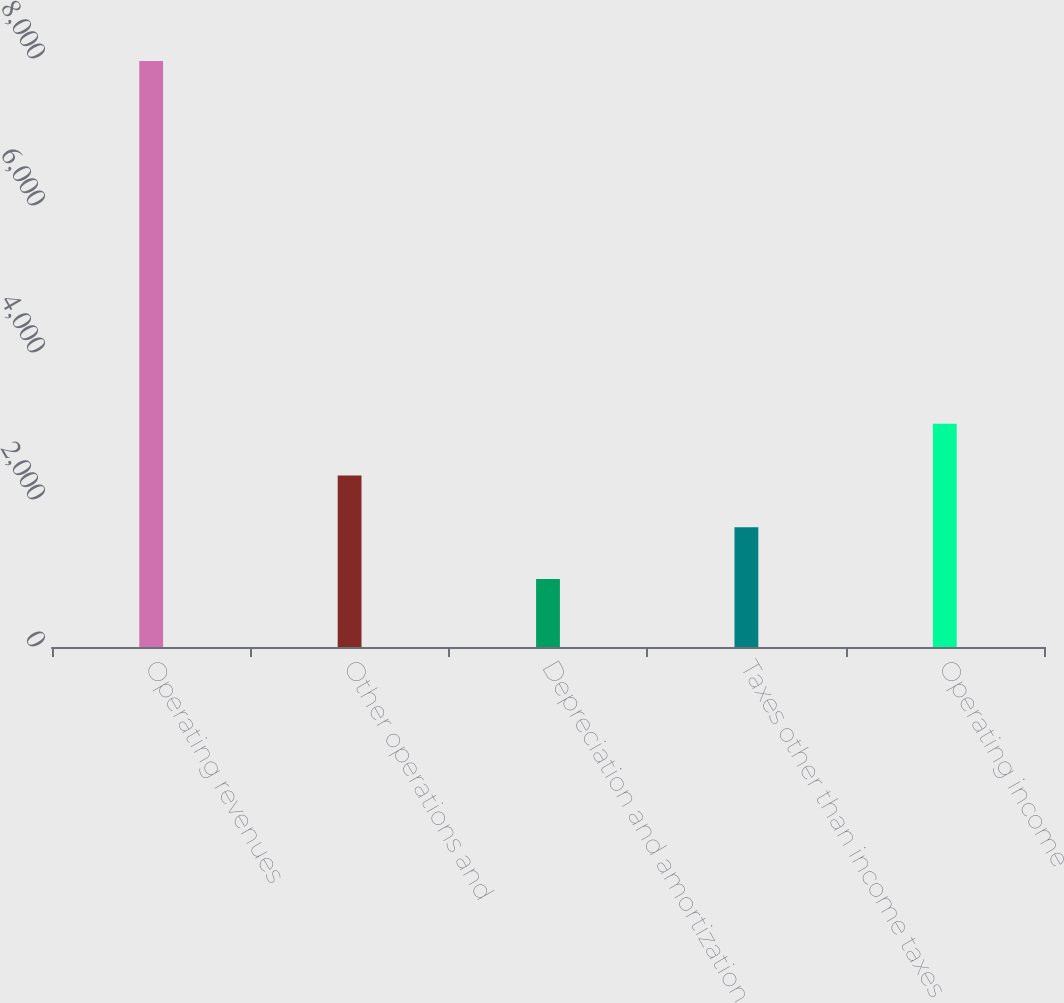Convert chart. <chart><loc_0><loc_0><loc_500><loc_500><bar_chart><fcel>Operating revenues<fcel>Other operations and<fcel>Depreciation and amortization<fcel>Taxes other than income taxes<fcel>Operating income<nl><fcel>7972<fcel>2334.4<fcel>925<fcel>1629.7<fcel>3039.1<nl></chart> 